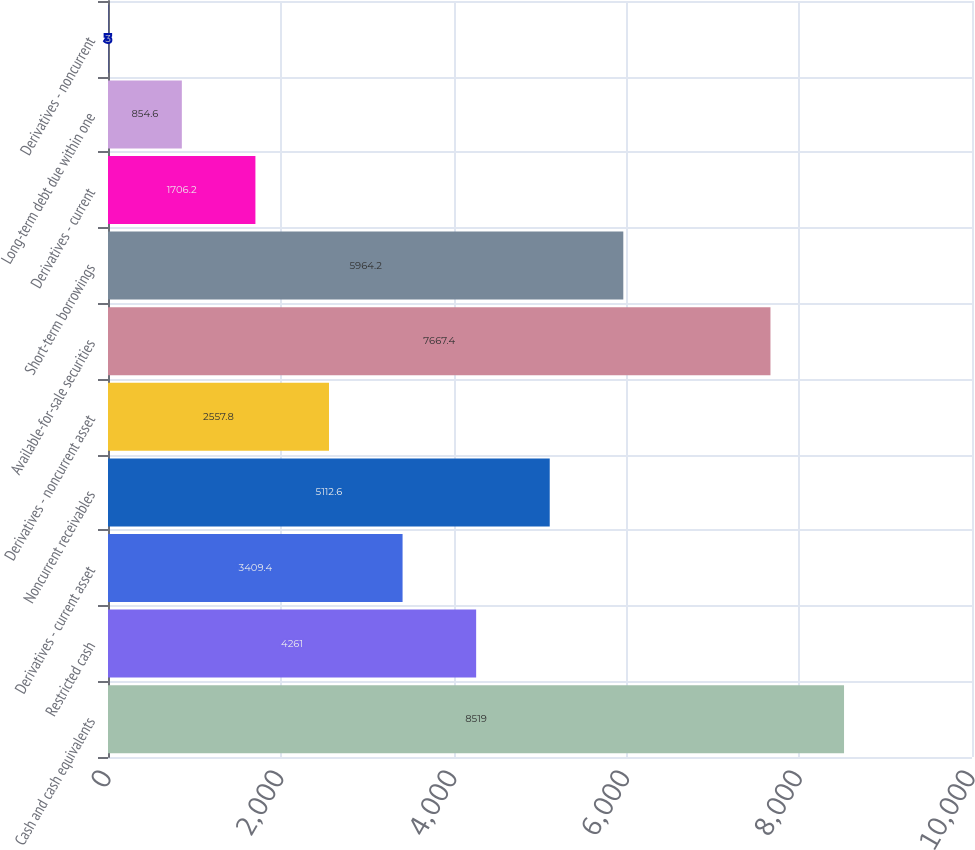<chart> <loc_0><loc_0><loc_500><loc_500><bar_chart><fcel>Cash and cash equivalents<fcel>Restricted cash<fcel>Derivatives - current asset<fcel>Noncurrent receivables<fcel>Derivatives - noncurrent asset<fcel>Available-for-sale securities<fcel>Short-term borrowings<fcel>Derivatives - current<fcel>Long-term debt due within one<fcel>Derivatives - noncurrent<nl><fcel>8519<fcel>4261<fcel>3409.4<fcel>5112.6<fcel>2557.8<fcel>7667.4<fcel>5964.2<fcel>1706.2<fcel>854.6<fcel>3<nl></chart> 